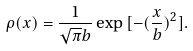Convert formula to latex. <formula><loc_0><loc_0><loc_500><loc_500>\rho ( x ) = \frac { 1 } { \sqrt { \pi } b } \exp { [ - ( \frac { x } { b } ) ^ { 2 } ] } .</formula> 